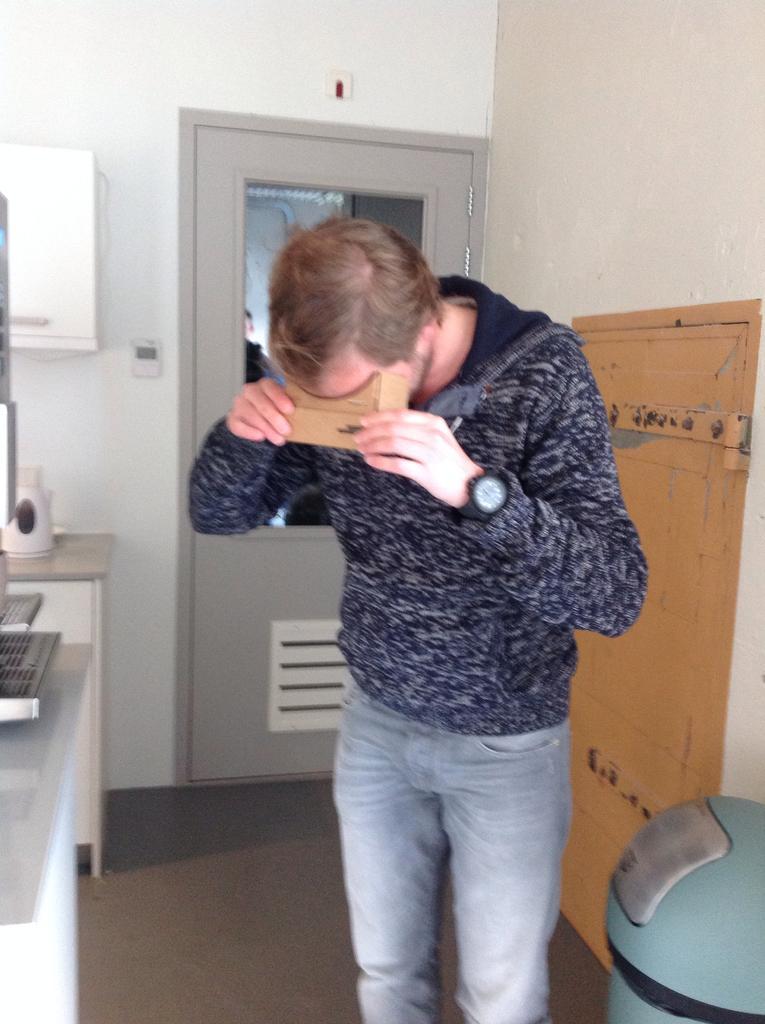Could you give a brief overview of what you see in this image? In this image a person is standing on the floor. He is holding an object in his hand. Left side there is a cabinet having few objects on it. A cupboard is attached to the wall having a door. Right bottom there is an object on the floor. 